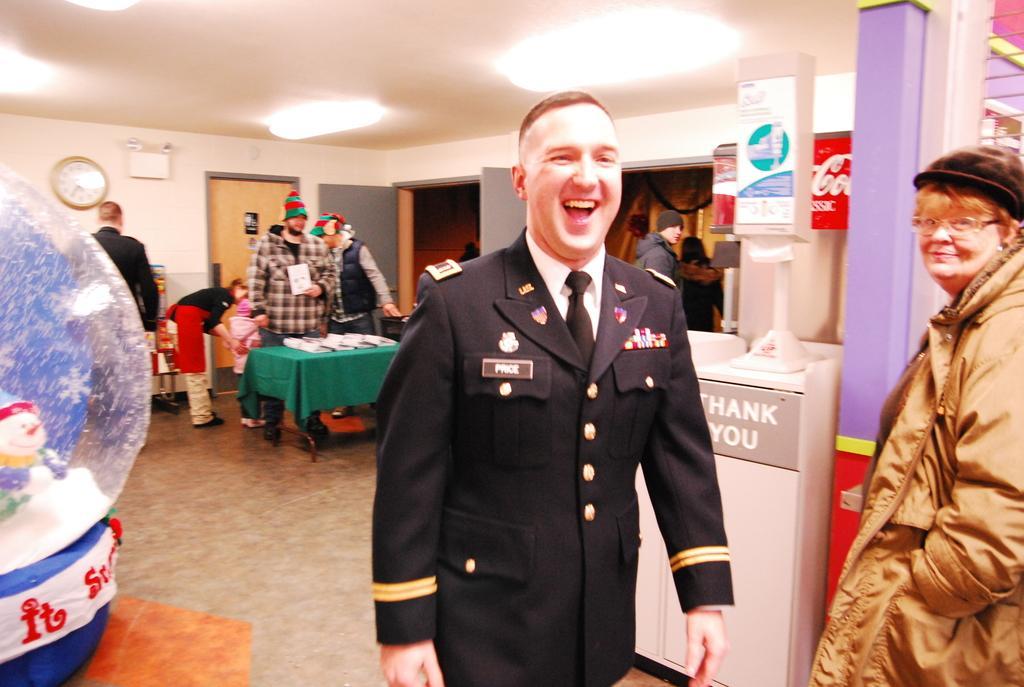Could you give a brief overview of what you see in this image? As we can see in the picture that there are many people in a room. This man who is wearing a uniform and smiling, beside him is a women who is wearing a cap and spectacles. These are the lights, clock, table. 